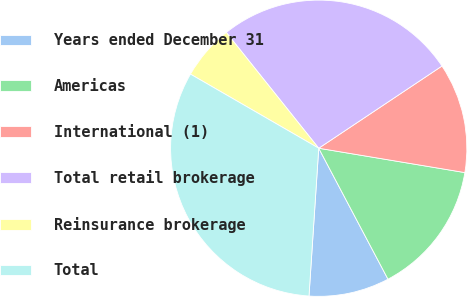Convert chart to OTSL. <chart><loc_0><loc_0><loc_500><loc_500><pie_chart><fcel>Years ended December 31<fcel>Americas<fcel>International (1)<fcel>Total retail brokerage<fcel>Reinsurance brokerage<fcel>Total<nl><fcel>8.79%<fcel>14.63%<fcel>11.99%<fcel>26.36%<fcel>5.94%<fcel>32.29%<nl></chart> 